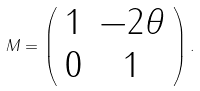Convert formula to latex. <formula><loc_0><loc_0><loc_500><loc_500>M = \left ( \begin{array} { c c } 1 & - 2 \theta \\ 0 & 1 \end{array} \right ) .</formula> 